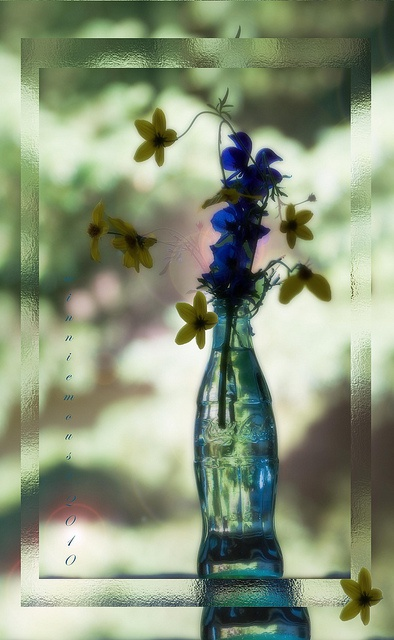Describe the objects in this image and their specific colors. I can see a vase in green, teal, and black tones in this image. 